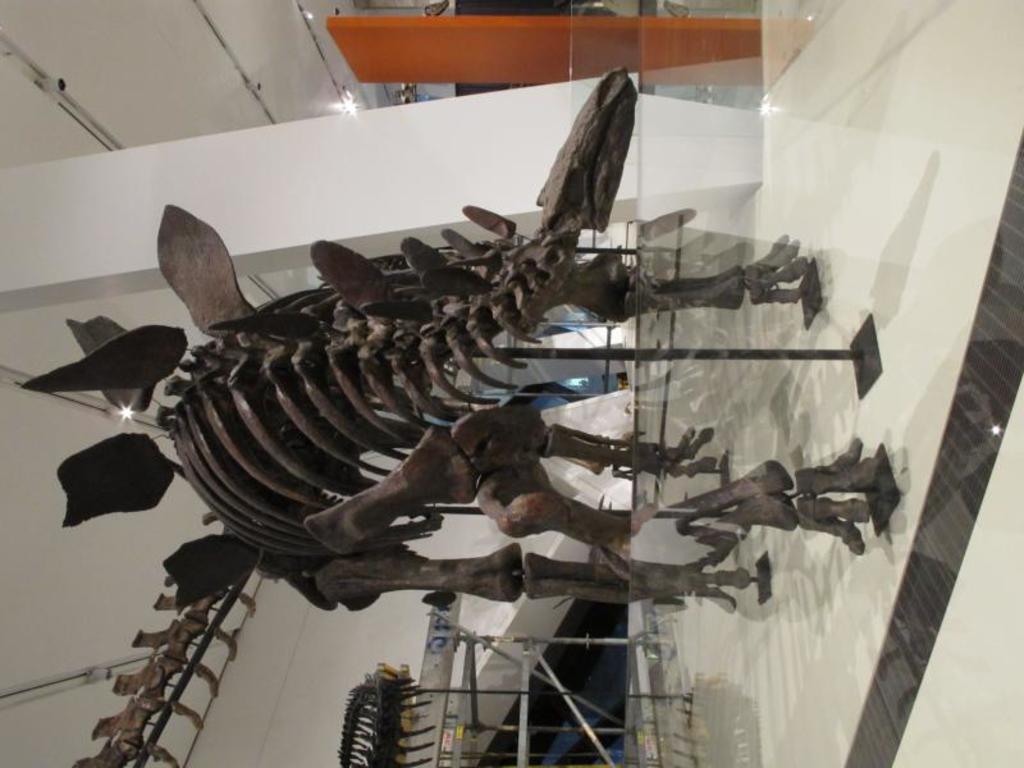Could you give a brief overview of what you see in this image? As we can see in the image there is wall, table, lights, white color tiles and an animal skeleton. 